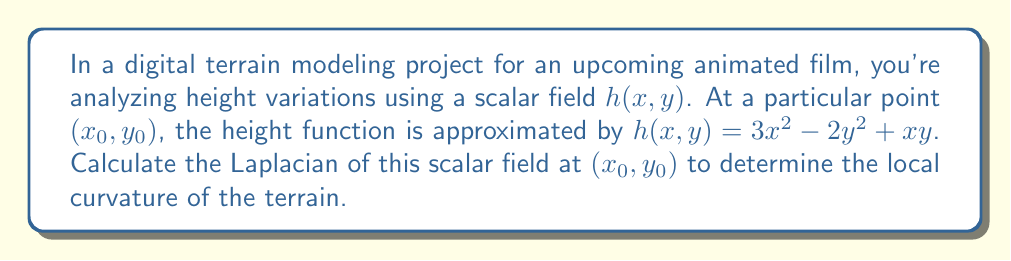Help me with this question. To solve this problem, we'll follow these steps:

1) The Laplacian of a scalar field in two dimensions is defined as:

   $$\nabla^2h = \frac{\partial^2h}{\partial x^2} + \frac{\partial^2h}{\partial y^2}$$

2) We need to calculate the second partial derivatives of $h$ with respect to $x$ and $y$.

3) First, let's find $\frac{\partial^2h}{\partial x^2}$:
   
   $\frac{\partial h}{\partial x} = 6x + y$
   $\frac{\partial^2h}{\partial x^2} = 6$

4) Now, let's find $\frac{\partial^2h}{\partial y^2}$:
   
   $\frac{\partial h}{\partial y} = -4y + x$
   $\frac{\partial^2h}{\partial y^2} = -4$

5) Now we can substitute these values into the Laplacian formula:

   $$\nabla^2h = \frac{\partial^2h}{\partial x^2} + \frac{\partial^2h}{\partial y^2} = 6 + (-4) = 2$$

6) The Laplacian at $(x_0, y_0)$ is 2, which is constant regardless of the specific point we choose. This indicates that the curvature of the terrain is uniform across this local approximation.
Answer: $\nabla^2h = 2$ 